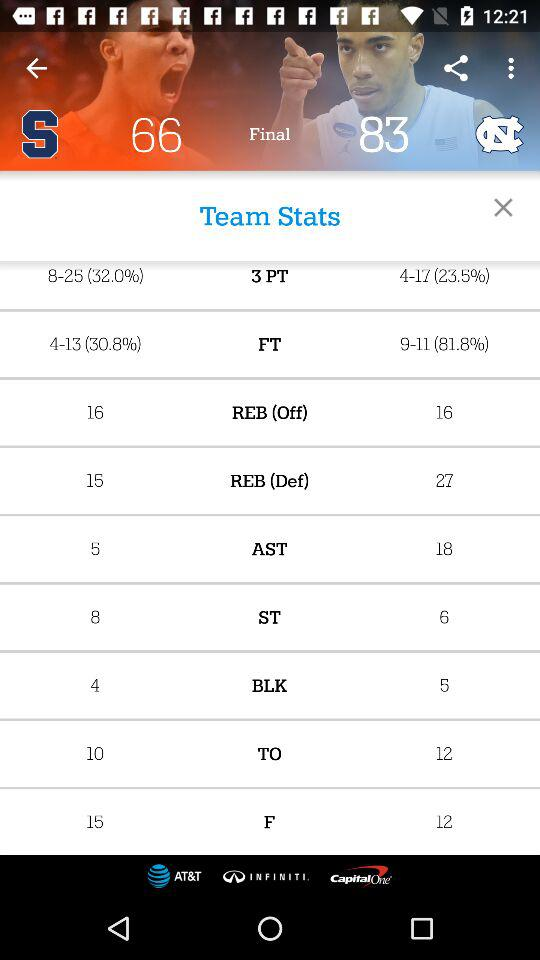How many rebounds were made by North Carolina team in defense? The number of rebounds made by North Carolina team in defense was 27. 